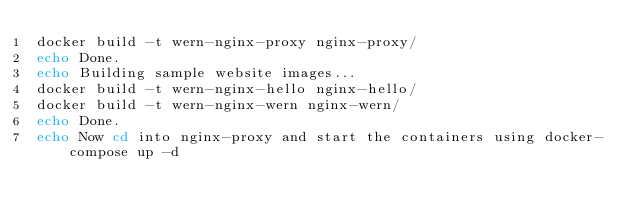Convert code to text. <code><loc_0><loc_0><loc_500><loc_500><_Bash_>docker build -t wern-nginx-proxy nginx-proxy/
echo Done.
echo Building sample website images...
docker build -t wern-nginx-hello nginx-hello/
docker build -t wern-nginx-wern nginx-wern/
echo Done.
echo Now cd into nginx-proxy and start the containers using docker-compose up -d</code> 